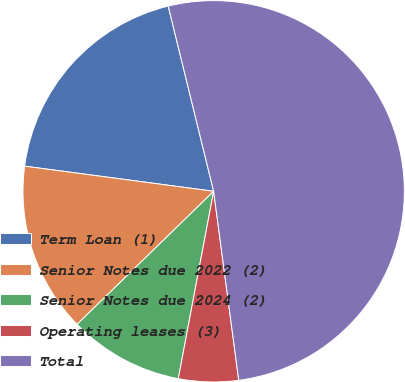Convert chart to OTSL. <chart><loc_0><loc_0><loc_500><loc_500><pie_chart><fcel>Term Loan (1)<fcel>Senior Notes due 2022 (2)<fcel>Senior Notes due 2024 (2)<fcel>Operating leases (3)<fcel>Total<nl><fcel>19.07%<fcel>14.4%<fcel>9.74%<fcel>5.07%<fcel>51.73%<nl></chart> 